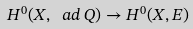Convert formula to latex. <formula><loc_0><loc_0><loc_500><loc_500>H ^ { 0 } ( X , \ a d \, Q ) \to H ^ { 0 } ( X , E )</formula> 